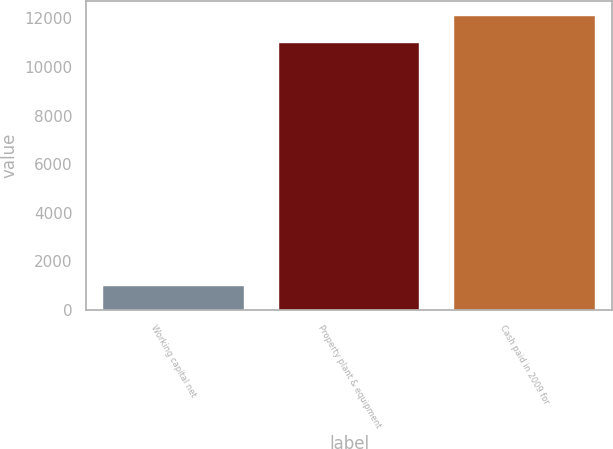<chart> <loc_0><loc_0><loc_500><loc_500><bar_chart><fcel>Working capital net<fcel>Property plant & equipment<fcel>Cash paid in 2009 for<nl><fcel>1000<fcel>11000<fcel>12100<nl></chart> 